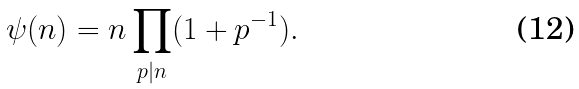<formula> <loc_0><loc_0><loc_500><loc_500>\psi ( n ) = n \prod _ { p | n } ( 1 + p ^ { - 1 } ) .</formula> 